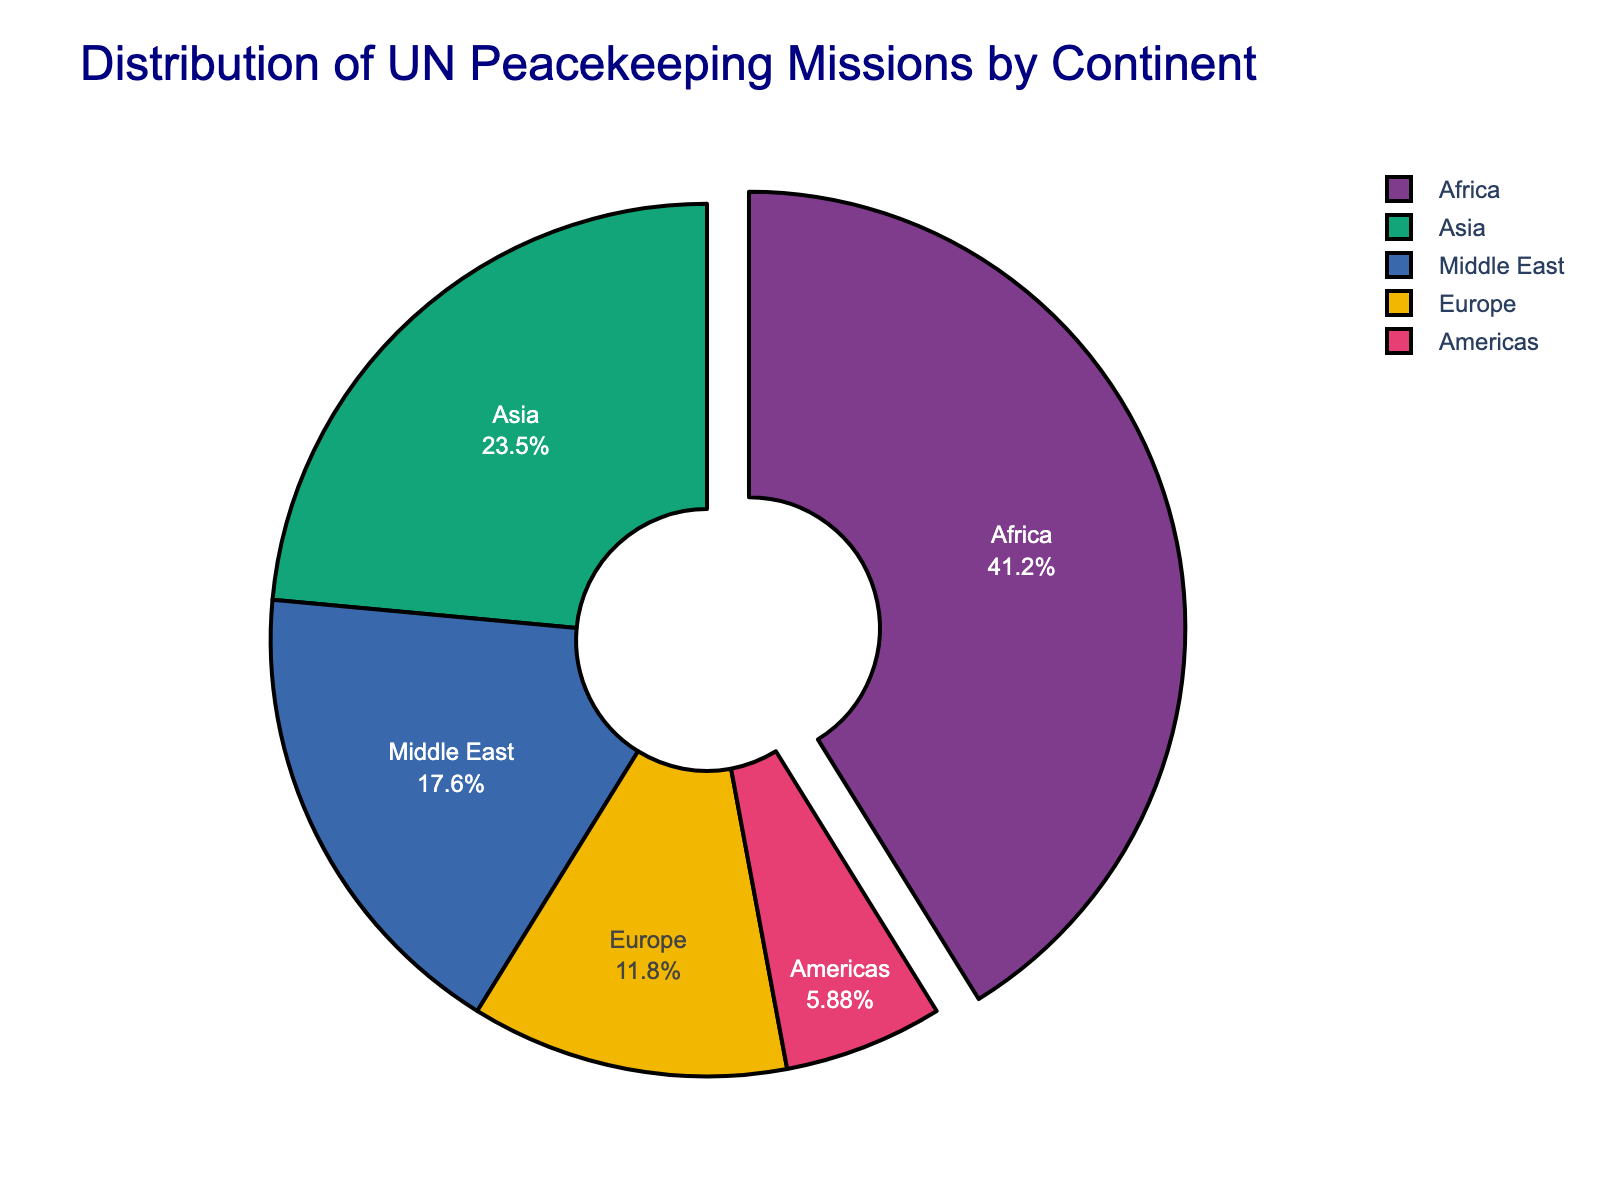What is the continent with the largest number of UN peacekeeping missions? Looking at the figure, identify the segment that occupies the largest area. The largest segment corresponds to Africa, with 7 missions.
Answer: Africa What percentage of UN peacekeeping missions are in Europe? Locate the segment labeled Europe and identify the percentage value displayed inside it. The segment for Europe shows 10%.
Answer: 10% How many more missions are in Africa compared to Asia? Refer to the figure to find the numbers for Africa (7) and Asia (4). Subtract the number of missions in Asia from the number of missions in Africa (7 - 4).
Answer: 3 Which continents have fewer than 3 UN peacekeeping missions? From the figure, identify the segments for each continent and their corresponding values. Only Europe (2) and Americas (1) have fewer than 3 missions.
Answer: Europe, Americas What is the proportion of UN peacekeeping missions in the Middle East relative to the total number of missions? First, determine the total number of missions by summing all the values: 7 (Africa) + 4 (Asia) + 2 (Europe) + 3 (Middle East) + 1 (Americas) = 17. Then, find the proportion for the Middle East: 3/17.
Answer: 3/17 What fraction of the total UN peacekeeping missions does Asia represent? The number of missions in Asia is 4. Sum the total number of missions from all continents: 7 + 4 + 2 + 3 + 1 = 17. The fraction is 4/17.
Answer: 4/17 If we combine the number of missions in Africa and Europe, what percentage of the total number of missions does this represent? First calculate the combined number of missions in Africa (7) and Europe (2): 7 + 2 = 9. Then, find the total number from all continents: 7 + 4 + 2 + 3 + 1 = 17. Calculate the percentage: (9/17) × 100 ≈ 52.94%.
Answer: 52.94% Which segment is visually pulled out from the pie chart, and what does it represent? Observe the figure to see which segment is visually separated or pulled out. This segment represents Africa.
Answer: Africa 